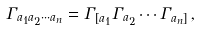<formula> <loc_0><loc_0><loc_500><loc_500>\Gamma _ { a _ { 1 } a _ { 2 } \cdots a _ { n } } = \Gamma _ { [ a _ { 1 } } \Gamma _ { a _ { 2 } } \cdots \Gamma _ { a _ { n } ] } \, ,</formula> 